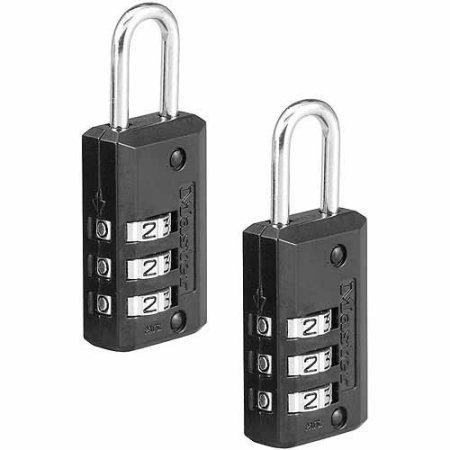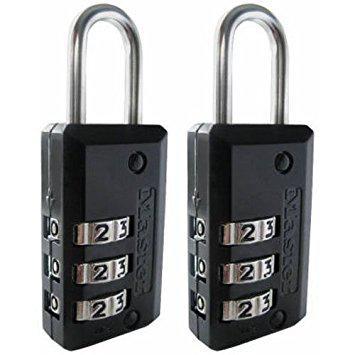The first image is the image on the left, the second image is the image on the right. Assess this claim about the two images: "All combination locks have black bodies with silver lock loops at the top, and black numbers on sliding silver number belts.". Correct or not? Answer yes or no. Yes. The first image is the image on the left, the second image is the image on the right. Given the left and right images, does the statement "All of the locks have black bodies with a metal ring." hold true? Answer yes or no. Yes. 